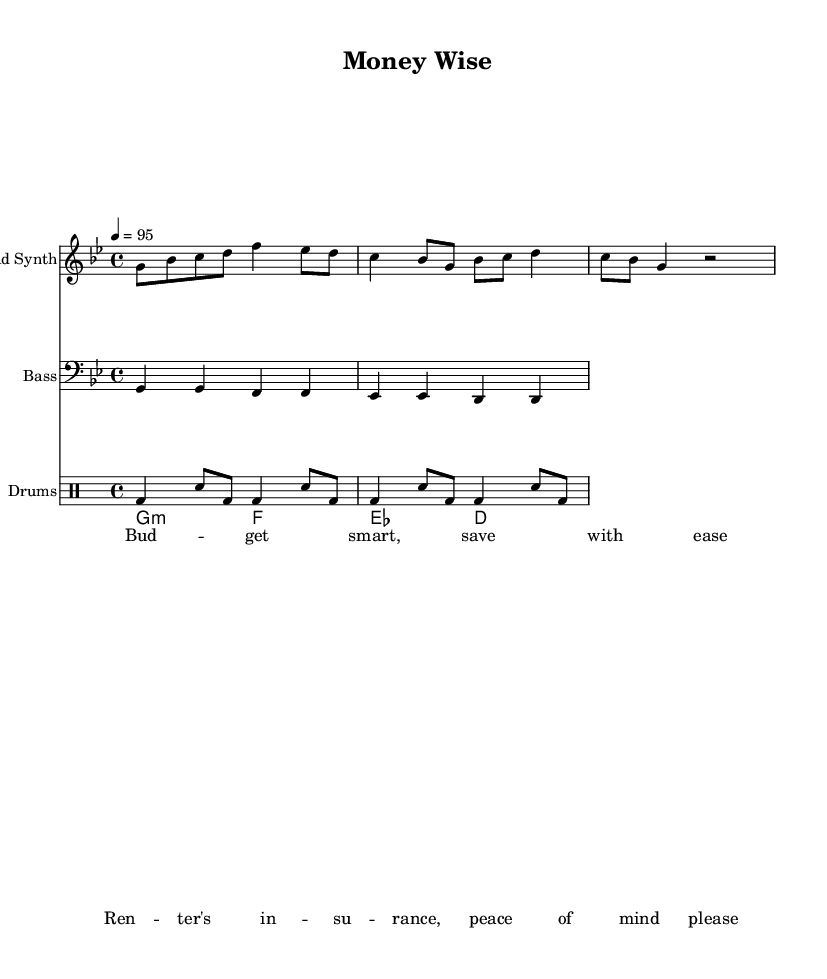What is the key signature of this music? The key signature is G minor, which has two flats (B♭ and E♭).
Answer: G minor What is the time signature of this music? The time signature shown in the music is 4/4, which means there are four beats per measure.
Answer: 4/4 What is the tempo marking of this piece? The tempo marking indicates a speed of 95 beats per minute, specified at the beginning of the score.
Answer: 95 How many measures are in the lead synth part? The lead synth part consists of three distinct measures based on the notated rhythms.
Answer: 3 What type of chord is used in the piano section? The chord labeled in the piano section is a G minor chord, as indicated by "g:m".
Answer: G minor What instrument plays the bass line in this score? The bass line is written for the bass instrument, which is indicated by the clef marking in the line.
Answer: Bass What is the main theme of the lyrics in this piece? The lyrics focus on budgeting and financial independence, which is a common theme in hip-hop lyrics emphasizing money management.
Answer: Budgeting and financial independence 